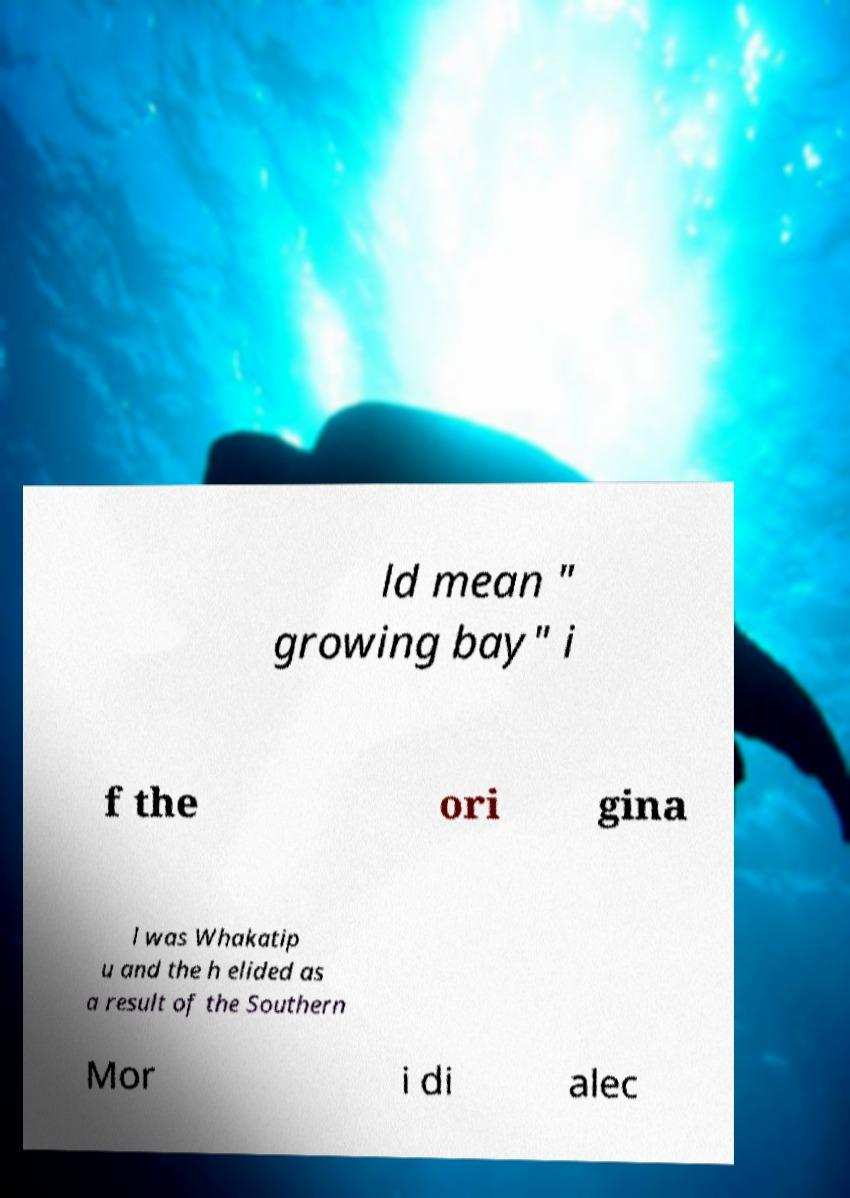Could you assist in decoding the text presented in this image and type it out clearly? ld mean " growing bay" i f the ori gina l was Whakatip u and the h elided as a result of the Southern Mor i di alec 